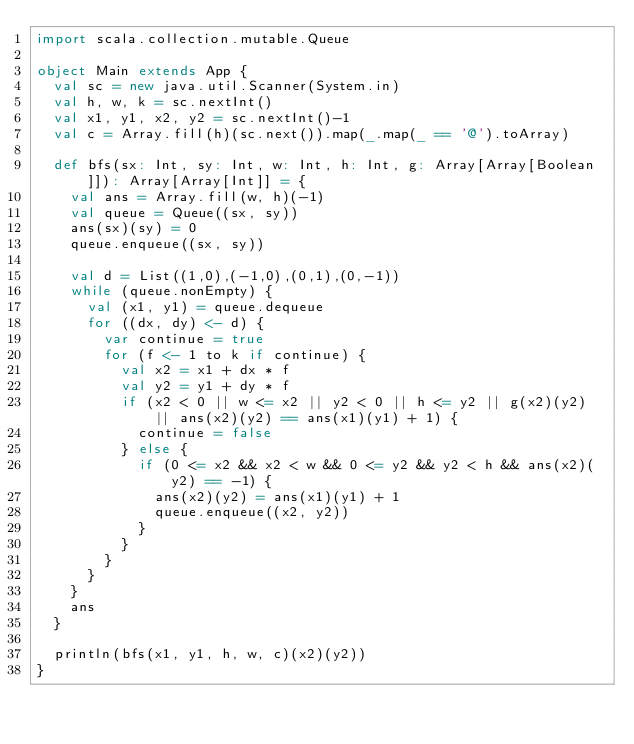Convert code to text. <code><loc_0><loc_0><loc_500><loc_500><_Scala_>import scala.collection.mutable.Queue

object Main extends App {
  val sc = new java.util.Scanner(System.in)
  val h, w, k = sc.nextInt()
  val x1, y1, x2, y2 = sc.nextInt()-1
  val c = Array.fill(h)(sc.next()).map(_.map(_ == '@').toArray)

  def bfs(sx: Int, sy: Int, w: Int, h: Int, g: Array[Array[Boolean]]): Array[Array[Int]] = {
    val ans = Array.fill(w, h)(-1)
    val queue = Queue((sx, sy))
    ans(sx)(sy) = 0
    queue.enqueue((sx, sy))

    val d = List((1,0),(-1,0),(0,1),(0,-1))
    while (queue.nonEmpty) {
      val (x1, y1) = queue.dequeue
      for ((dx, dy) <- d) {
        var continue = true
        for (f <- 1 to k if continue) {
          val x2 = x1 + dx * f
          val y2 = y1 + dy * f
          if (x2 < 0 || w <= x2 || y2 < 0 || h <= y2 || g(x2)(y2) || ans(x2)(y2) == ans(x1)(y1) + 1) {
            continue = false
          } else {
            if (0 <= x2 && x2 < w && 0 <= y2 && y2 < h && ans(x2)(y2) == -1) {
              ans(x2)(y2) = ans(x1)(y1) + 1
              queue.enqueue((x2, y2))
            }
          }
        }
      }
    }
    ans
  }

  println(bfs(x1, y1, h, w, c)(x2)(y2))
}
</code> 